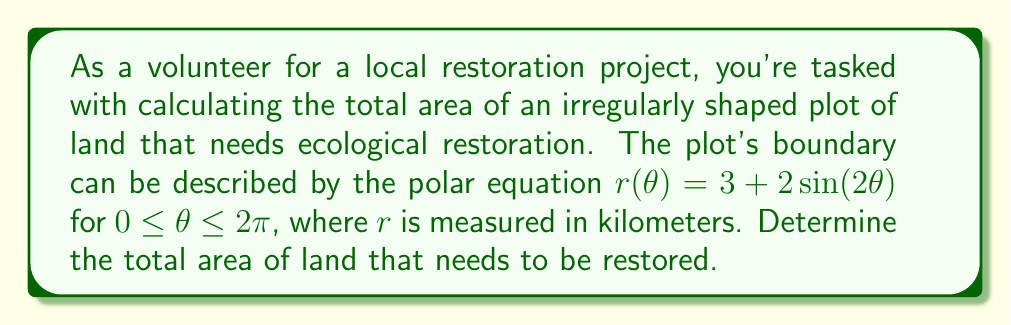Give your solution to this math problem. To solve this problem, we'll use the formula for the area of a region in polar coordinates:

$$A = \frac{1}{2} \int_{0}^{2\pi} [r(\theta)]^2 d\theta$$

Step 1: Substitute the given function $r(\theta) = 3 + 2\sin(2\theta)$ into the area formula:

$$A = \frac{1}{2} \int_{0}^{2\pi} [3 + 2\sin(2\theta)]^2 d\theta$$

Step 2: Expand the squared term:

$$A = \frac{1}{2} \int_{0}^{2\pi} [9 + 12\sin(2\theta) + 4\sin^2(2\theta)] d\theta$$

Step 3: Integrate each term separately:

$$\begin{align*}
A &= \frac{1}{2} \left[ 9\theta - 6\cos(2\theta) + 2\theta - \sin(4\theta)/2 \right]_{0}^{2\pi} \\
&= \frac{1}{2} \left[ (18\pi - 6\cos(4\pi) + 4\pi - \sin(8\pi)/2) - (0 - 6\cos(0) + 0 - \sin(0)/2) \right]
\end{align*}$$

Step 4: Simplify, noting that $\cos(4\pi) = 1$ and $\sin(8\pi) = 0$:

$$\begin{align*}
A &= \frac{1}{2} \left[ 22\pi - 6 + 6 \right] \\
&= \frac{1}{2} [22\pi] \\
&= 11\pi
\end{align*}$$

Therefore, the total area of land that needs to be restored is $11\pi$ square kilometers.
Answer: $11\pi$ square kilometers 